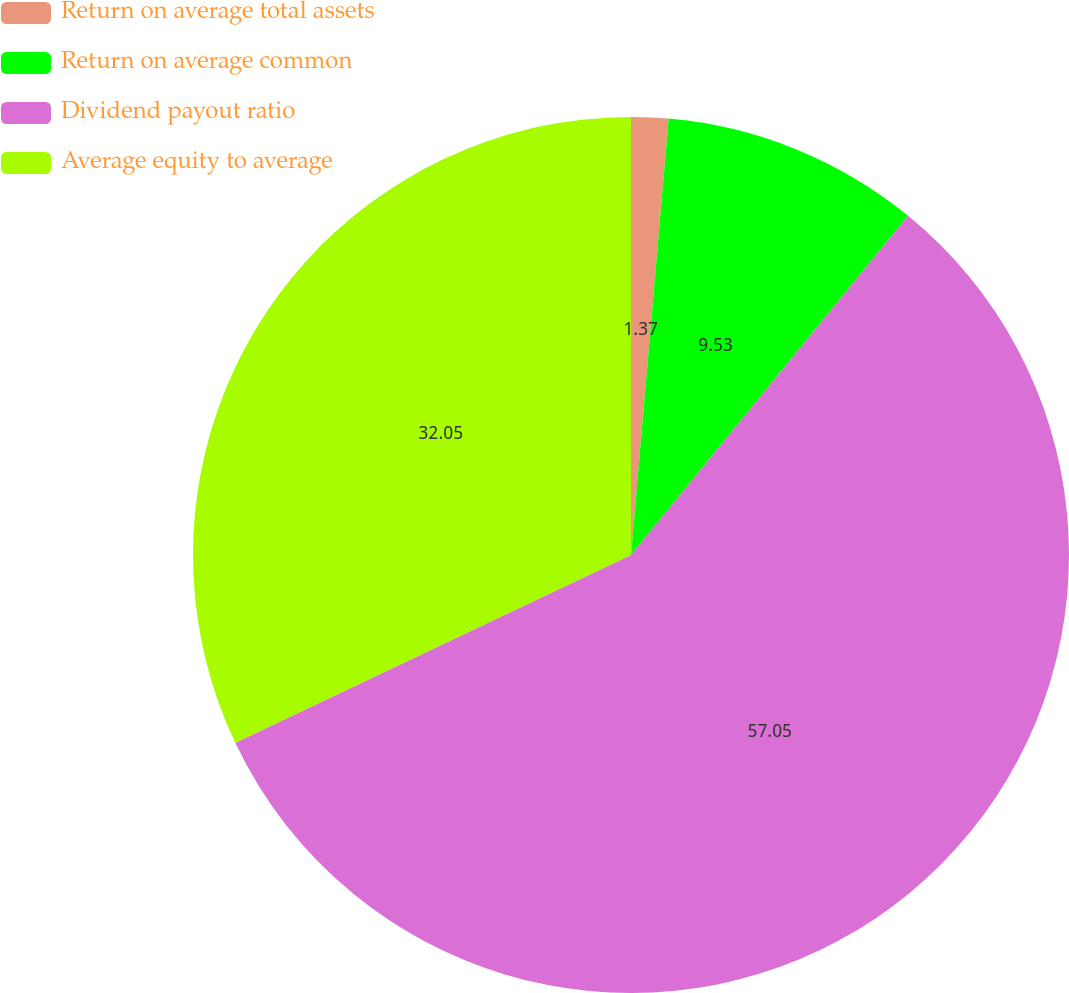Convert chart to OTSL. <chart><loc_0><loc_0><loc_500><loc_500><pie_chart><fcel>Return on average total assets<fcel>Return on average common<fcel>Dividend payout ratio<fcel>Average equity to average<nl><fcel>1.37%<fcel>9.53%<fcel>57.04%<fcel>32.05%<nl></chart> 